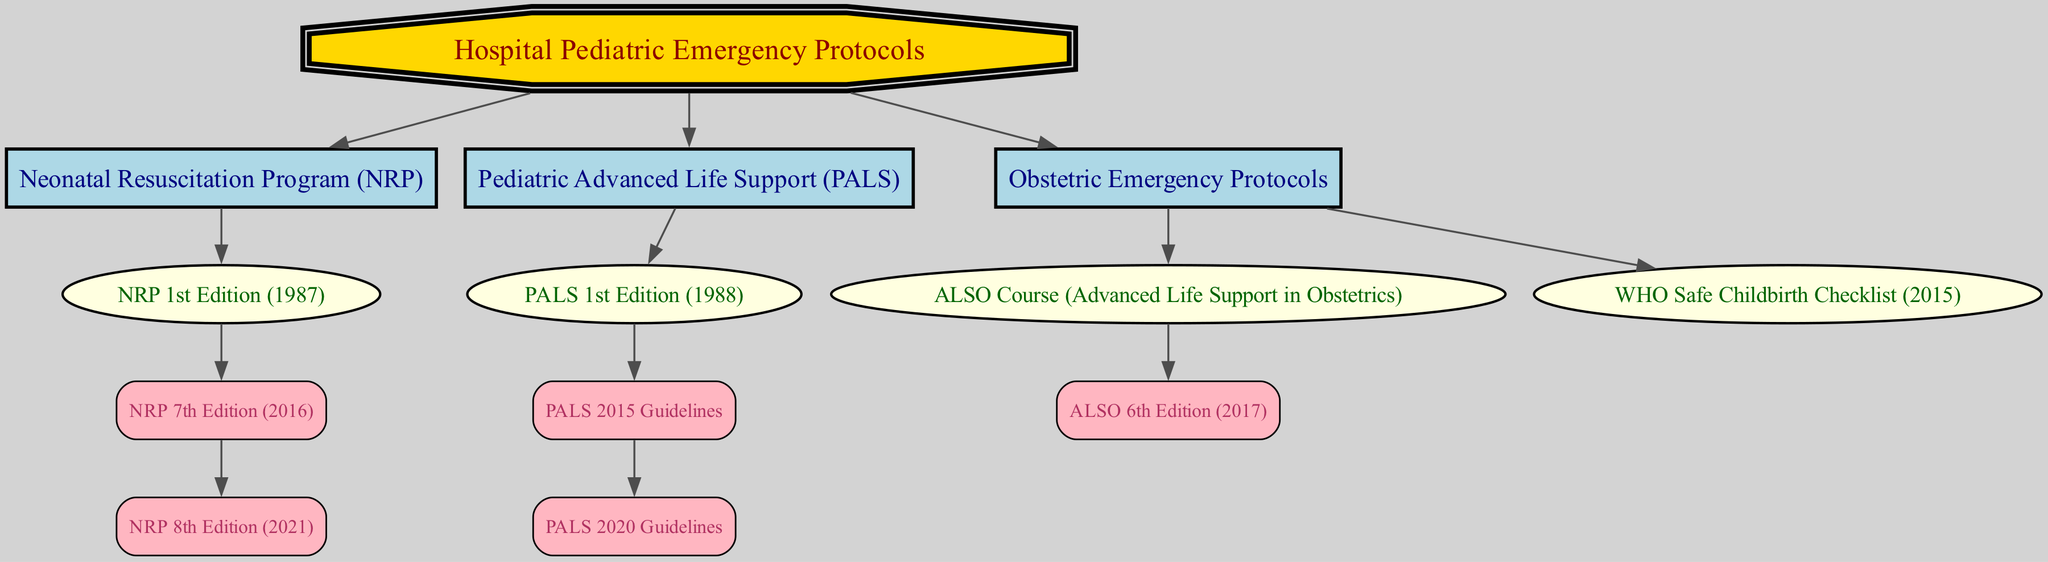What is the root node of the family tree? The root node is labeled as "Hospital Pediatric Emergency Protocols," which is the central concept from which all other nodes branch out.
Answer: Hospital Pediatric Emergency Protocols How many main branches are present under the root node? There are three main branches listed under the root node: Neonatal Resuscitation Program (NRP), Pediatric Advanced Life Support (PALS), and Obstetric Emergency Protocols.
Answer: 3 What is the first edition year of the Pediatric Advanced Life Support? The first edition of Pediatric Advanced Life Support (PALS) is shown to be published in 1988, which is indicated directly under the PALS branch.
Answer: 1988 Which edition follows the 7th edition of the Neonatal Resuscitation Program? The 8th edition follows the 7th edition of the Neonatal Resuscitation Program (NRP), showing a direct progression in the lineage of the NRP.
Answer: NRP 8th Edition (2021) How many editions of the Pediatric Advanced Life Support were published before the 2020 guidelines? There are two editions listed before the PALS 2020 Guidelines: PALS 1st Edition (1988) and PALS 2015 Guidelines, indicating a progression over the years.
Answer: 2 What specific protocol is associated with the year 2015 under Obstetric Emergency Protocols? The year 2015 is associated with the "WHO Safe Childbirth Checklist," which is listed as a specific protocol under the Obstetric Emergency Protocols branch.
Answer: WHO Safe Childbirth Checklist (2015) Which protocol has an edition published in 2017? The Advanced Life Support in Obstetrics (ALSO) Course has the 6th edition published in 2017, which can be identified as a child node under the Obstetric Emergency Protocols.
Answer: ALSO 6th Edition (2017) How does the Neonatal Resuscitation Program's lineage indicate improvements over the years? The lineage indicates improvements through a sequence beginning with the 1st Edition in 1987, followed by updated editions (7th in 2016 and 8th in 2021), each typically reflecting advancements in practices based on research and clinical feedback.
Answer: Improved editions from 1987 to 2021 What is the visual representation of the root node in terms of shape? The root node's visual representation is a double octagon, which distinguishes it from other nodes in the diagram based on the structure and design chosen for hierarchy illustration.
Answer: Double octagon 